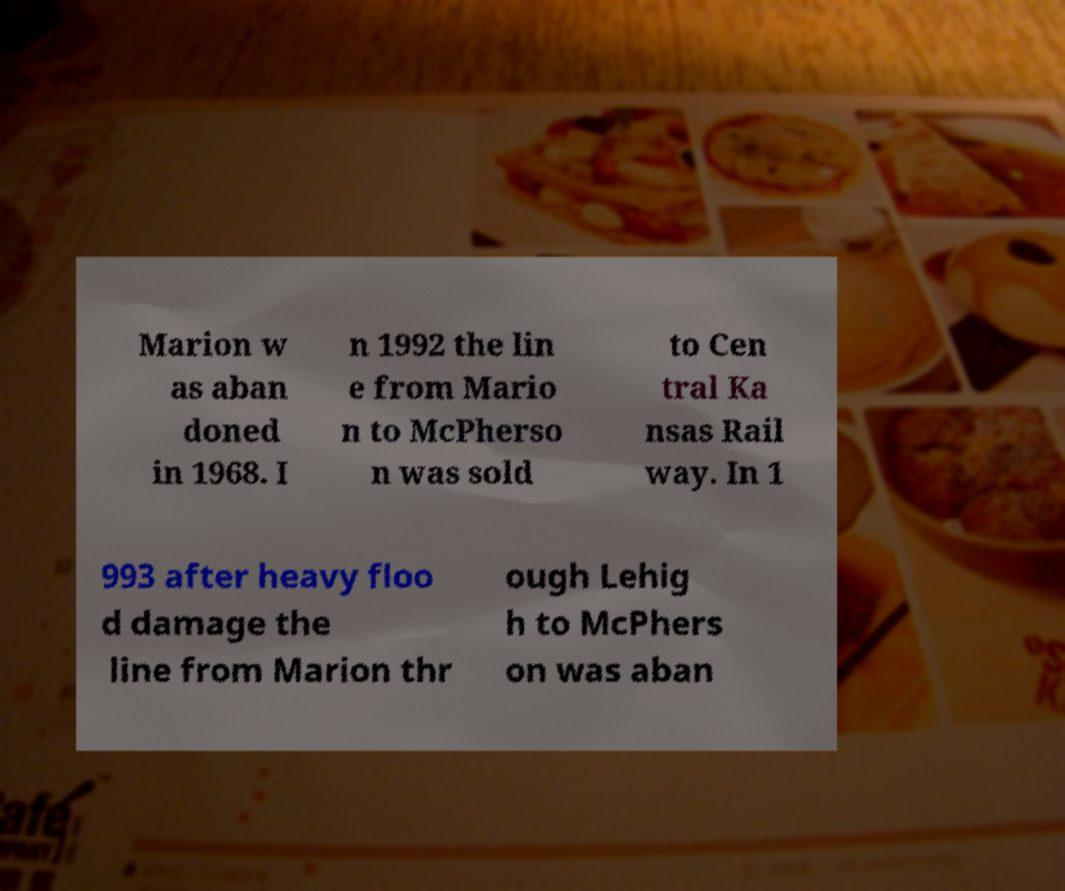Could you extract and type out the text from this image? Marion w as aban doned in 1968. I n 1992 the lin e from Mario n to McPherso n was sold to Cen tral Ka nsas Rail way. In 1 993 after heavy floo d damage the line from Marion thr ough Lehig h to McPhers on was aban 